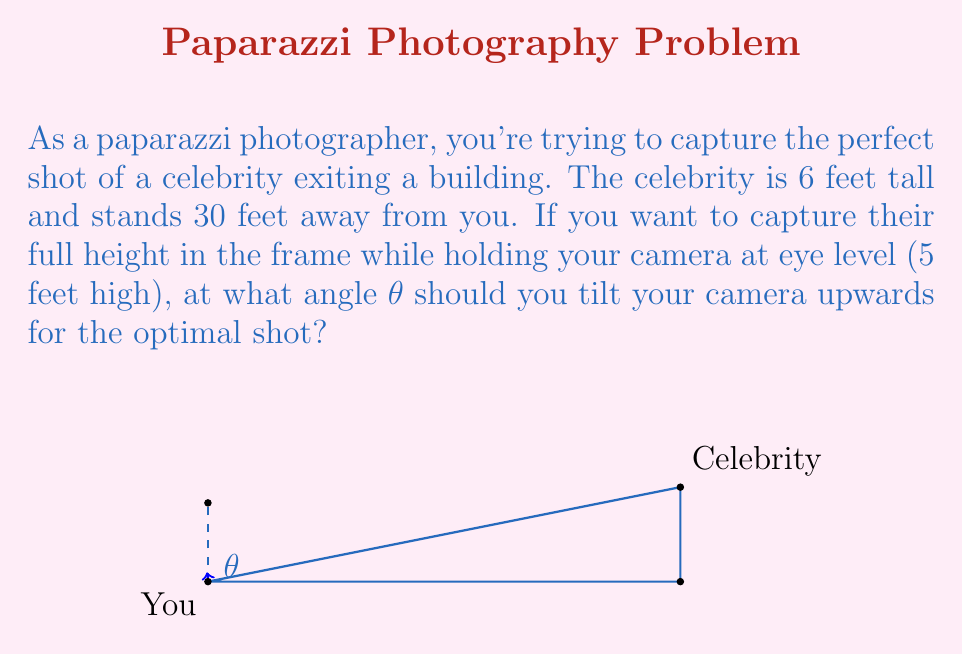What is the answer to this math problem? Let's approach this step-by-step using trigonometry:

1) First, we need to find the height difference between the top of the celebrity's head and your eye level:
   $\text{Height difference} = 6\text{ ft} - 5\text{ ft} = 1\text{ ft}$

2) Now we have a right triangle where:
   - The adjacent side is the distance to the celebrity (30 ft)
   - The opposite side is the height difference (1 ft)
   - The angle we're looking for is θ

3) We can use the tangent function to find this angle:

   $$\tan(\theta) = \frac{\text{opposite}}{\text{adjacent}} = \frac{1\text{ ft}}{30\text{ ft}} = \frac{1}{30}$$

4) To find θ, we need to take the inverse tangent (arctangent) of both sides:

   $$\theta = \arctan(\frac{1}{30})$$

5) Using a calculator or computer, we can evaluate this:

   $$\theta \approx 1.91\text{ degrees}$$

This angle will ensure that the top of the celebrity's head is just at the top of your camera frame when you're holding the camera at eye level.
Answer: $\theta = \arctan(\frac{1}{30}) \approx 1.91°$ 